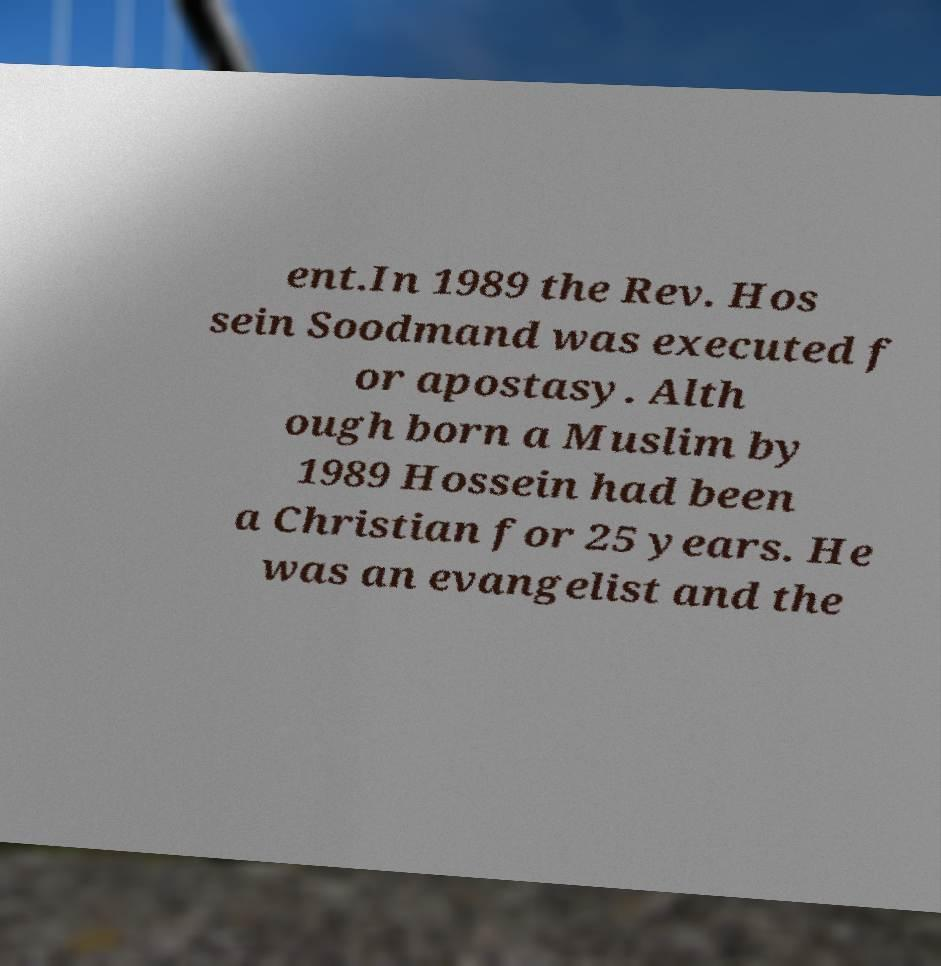Can you read and provide the text displayed in the image?This photo seems to have some interesting text. Can you extract and type it out for me? ent.In 1989 the Rev. Hos sein Soodmand was executed f or apostasy. Alth ough born a Muslim by 1989 Hossein had been a Christian for 25 years. He was an evangelist and the 